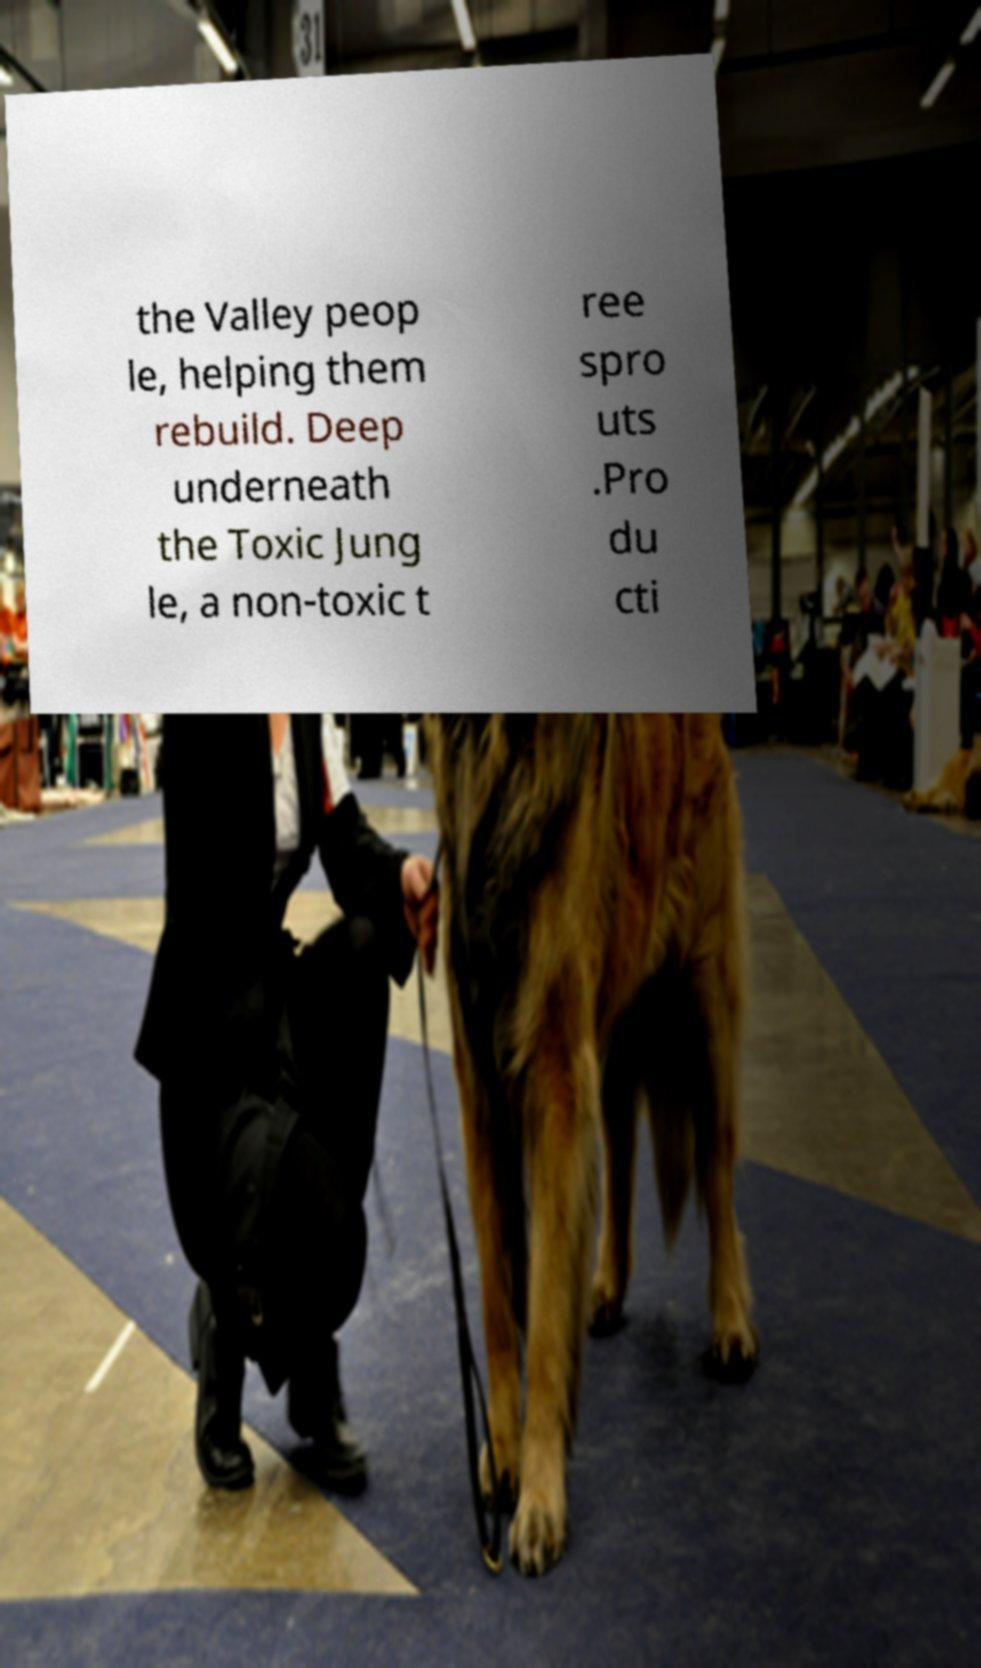Please read and relay the text visible in this image. What does it say? the Valley peop le, helping them rebuild. Deep underneath the Toxic Jung le, a non-toxic t ree spro uts .Pro du cti 